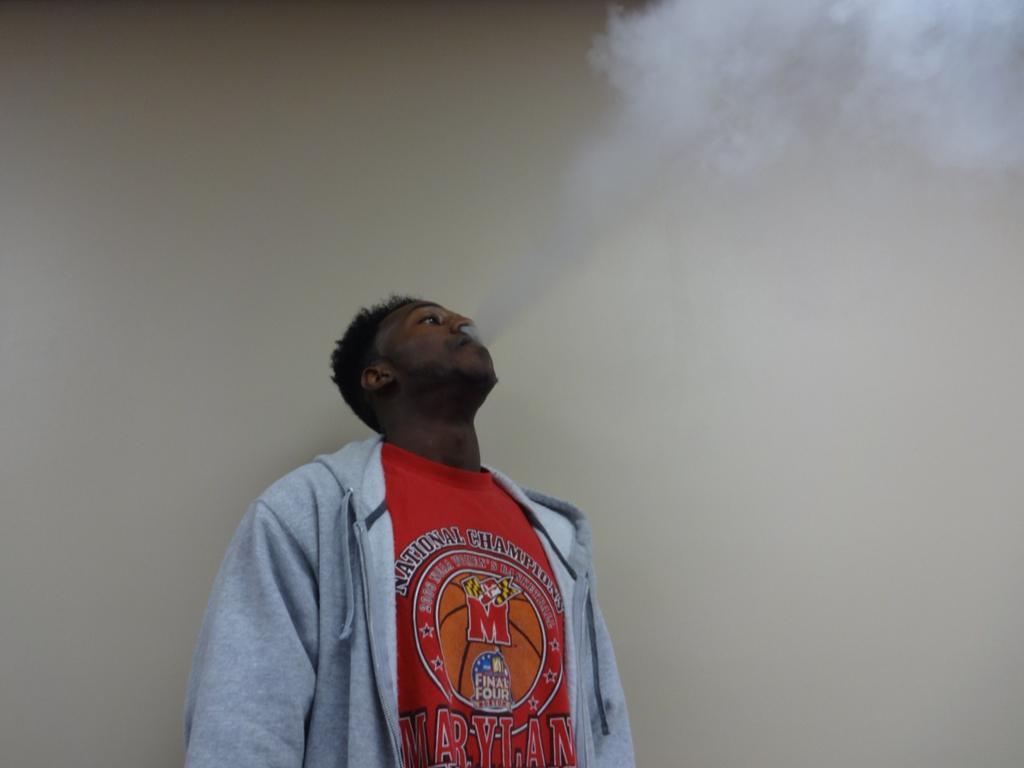<image>
Share a concise interpretation of the image provided. A man wearing a FInal Four shirt is blowing smoke out of his mouth. 